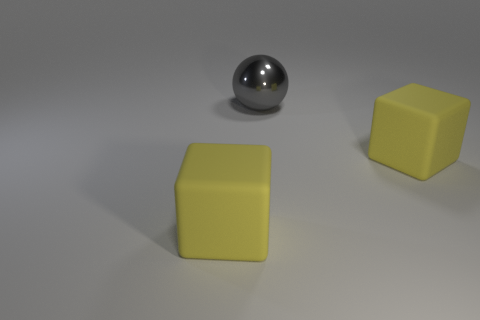Add 2 big red shiny blocks. How many objects exist? 5 Subtract all balls. How many objects are left? 2 Add 3 large gray shiny objects. How many large gray shiny objects are left? 4 Add 1 shiny spheres. How many shiny spheres exist? 2 Subtract 0 cyan cylinders. How many objects are left? 3 Subtract all big yellow metal cylinders. Subtract all yellow objects. How many objects are left? 1 